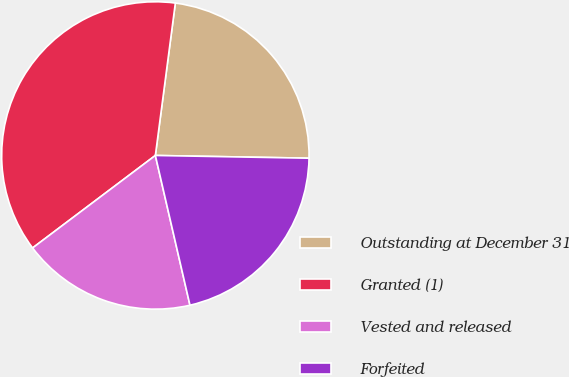Convert chart. <chart><loc_0><loc_0><loc_500><loc_500><pie_chart><fcel>Outstanding at December 31<fcel>Granted (1)<fcel>Vested and released<fcel>Forfeited<nl><fcel>23.21%<fcel>37.35%<fcel>18.34%<fcel>21.1%<nl></chart> 